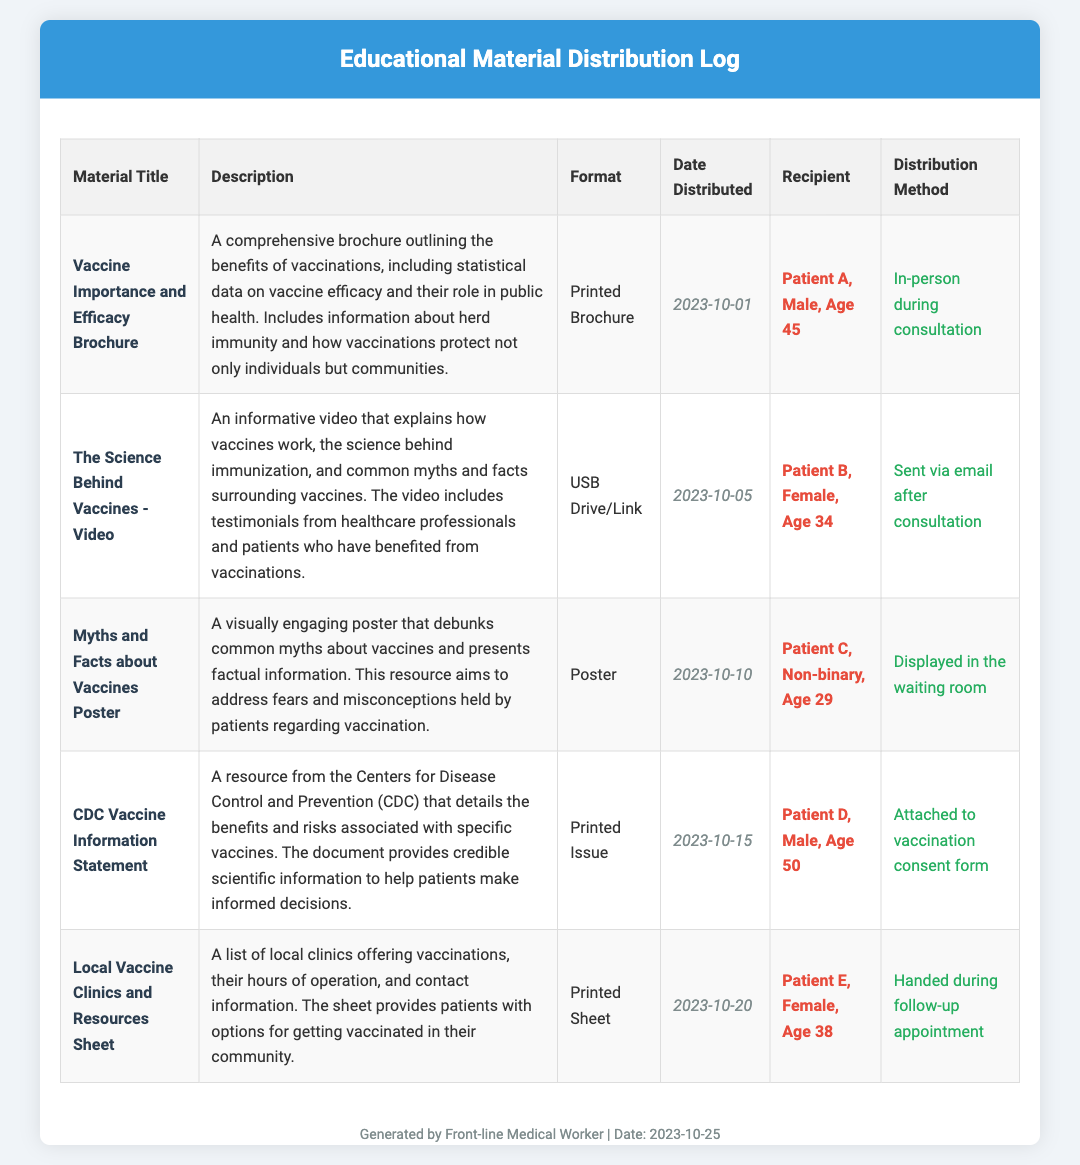What is the title of the first educational material? The title of the first educational material can be found in the first row of the table, which is "Vaccine Importance and Efficacy Brochure."
Answer: Vaccine Importance and Efficacy Brochure When was the "Local Vaccine Clinics and Resources Sheet" distributed? The distribution date is listed in the table under the corresponding educational material, which is "2023-10-20."
Answer: 2023-10-20 Who received the "CDC Vaccine Information Statement"? The recipient's details are specified in the table, and the name provided is "Patient D, Male, Age 50."
Answer: Patient D, Male, Age 50 What format was used for the "Myths and Facts about Vaccines Poster"? The format for this educational material can be identified in the table under the Format column, which states "Poster."
Answer: Poster Which educational material was sent via email after the consultation? The document lists this distribution method in the corresponding row, identifying it as "The Science Behind Vaccines - Video."
Answer: The Science Behind Vaccines - Video How many different educational materials are listed in the document? The total number can be counted by assessing the table entries, which shows there are five materials listed.
Answer: 5 What method was used to distribute the "Vaccine Importance and Efficacy Brochure"? This information is provided in the table, stating the method was "In-person during consultation."
Answer: In-person during consultation Which patient was provided with a video resource? The table will reveal this detail, indicating it was given to "Patient B, Female, Age 34."
Answer: Patient B, Female, Age 34 